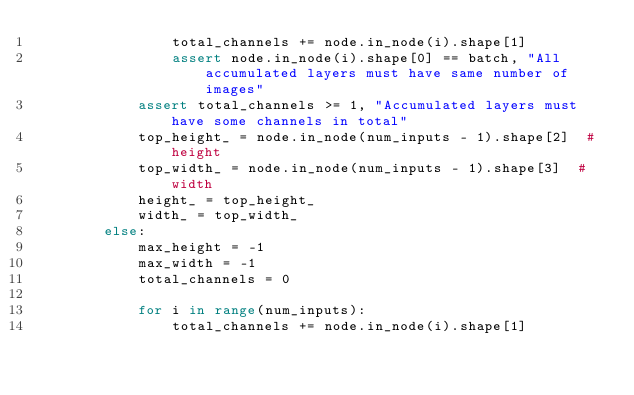Convert code to text. <code><loc_0><loc_0><loc_500><loc_500><_Python_>                total_channels += node.in_node(i).shape[1]
                assert node.in_node(i).shape[0] == batch, "All accumulated layers must have same number of images"
            assert total_channels >= 1, "Accumulated layers must have some channels in total"
            top_height_ = node.in_node(num_inputs - 1).shape[2]  # height
            top_width_ = node.in_node(num_inputs - 1).shape[3]  # width
            height_ = top_height_
            width_ = top_width_
        else:
            max_height = -1
            max_width = -1
            total_channels = 0

            for i in range(num_inputs):
                total_channels += node.in_node(i).shape[1]</code> 